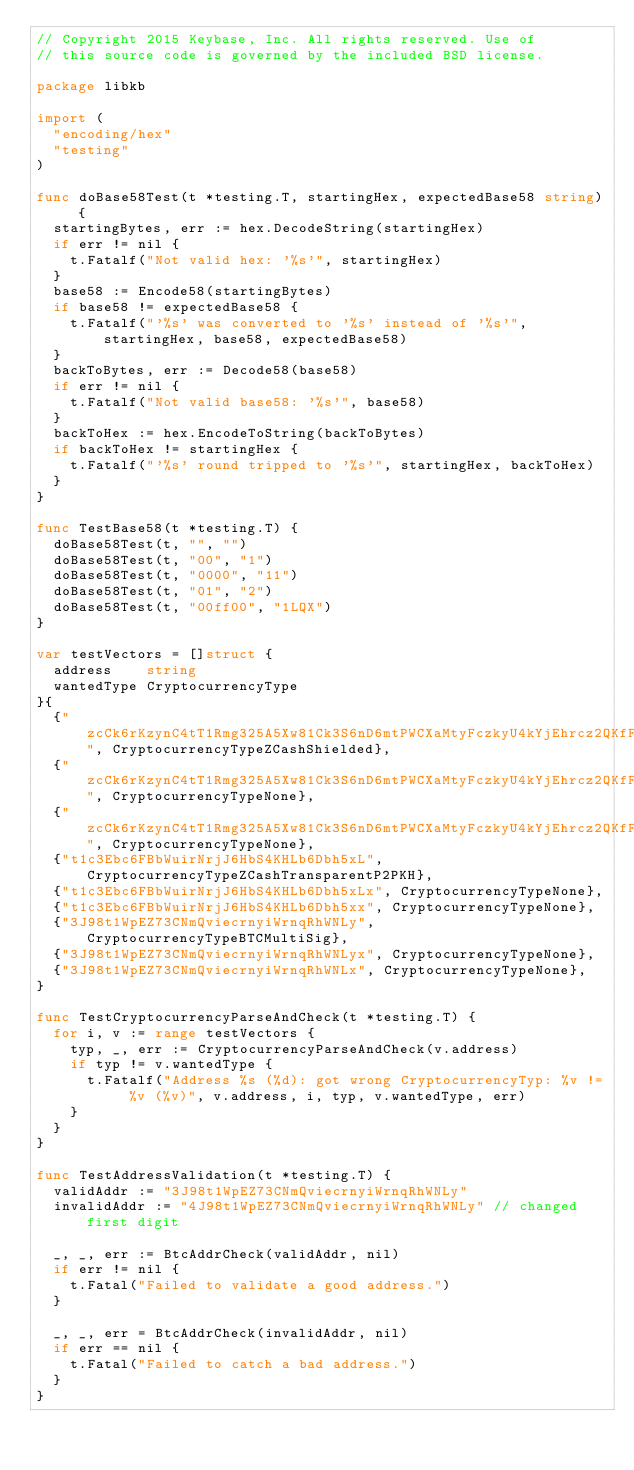<code> <loc_0><loc_0><loc_500><loc_500><_Go_>// Copyright 2015 Keybase, Inc. All rights reserved. Use of
// this source code is governed by the included BSD license.

package libkb

import (
	"encoding/hex"
	"testing"
)

func doBase58Test(t *testing.T, startingHex, expectedBase58 string) {
	startingBytes, err := hex.DecodeString(startingHex)
	if err != nil {
		t.Fatalf("Not valid hex: '%s'", startingHex)
	}
	base58 := Encode58(startingBytes)
	if base58 != expectedBase58 {
		t.Fatalf("'%s' was converted to '%s' instead of '%s'", startingHex, base58, expectedBase58)
	}
	backToBytes, err := Decode58(base58)
	if err != nil {
		t.Fatalf("Not valid base58: '%s'", base58)
	}
	backToHex := hex.EncodeToString(backToBytes)
	if backToHex != startingHex {
		t.Fatalf("'%s' round tripped to '%s'", startingHex, backToHex)
	}
}

func TestBase58(t *testing.T) {
	doBase58Test(t, "", "")
	doBase58Test(t, "00", "1")
	doBase58Test(t, "0000", "11")
	doBase58Test(t, "01", "2")
	doBase58Test(t, "00ff00", "1LQX")
}

var testVectors = []struct {
	address    string
	wantedType CryptocurrencyType
}{
	{"zcCk6rKzynC4tT1Rmg325A5Xw81Ck3S6nD6mtPWCXaMtyFczkyU4kYjEhrcz2QKfF5T2siWGyJNxWo43XWT3qk5YpPhFGj2", CryptocurrencyTypeZCashShielded},
	{"zcCk6rKzynC4tT1Rmg325A5Xw81Ck3S6nD6mtPWCXaMtyFczkyU4kYjEhrcz2QKfF5T2siWGyJNxWo43XWT3qk5YpPhFGj2x", CryptocurrencyTypeNone},
	{"zcCk6rKzynC4tT1Rmg325A5Xw81Ck3S6nD6mtPWCXaMtyFczkyU4kYjEhrcz2QKfF5T2siWGyJNxWo43XWT3qk5YpPhFGj3", CryptocurrencyTypeNone},
	{"t1c3Ebc6FBbWuirNrjJ6HbS4KHLb6Dbh5xL", CryptocurrencyTypeZCashTransparentP2PKH},
	{"t1c3Ebc6FBbWuirNrjJ6HbS4KHLb6Dbh5xLx", CryptocurrencyTypeNone},
	{"t1c3Ebc6FBbWuirNrjJ6HbS4KHLb6Dbh5xx", CryptocurrencyTypeNone},
	{"3J98t1WpEZ73CNmQviecrnyiWrnqRhWNLy", CryptocurrencyTypeBTCMultiSig},
	{"3J98t1WpEZ73CNmQviecrnyiWrnqRhWNLyx", CryptocurrencyTypeNone},
	{"3J98t1WpEZ73CNmQviecrnyiWrnqRhWNLx", CryptocurrencyTypeNone},
}

func TestCryptocurrencyParseAndCheck(t *testing.T) {
	for i, v := range testVectors {
		typ, _, err := CryptocurrencyParseAndCheck(v.address)
		if typ != v.wantedType {
			t.Fatalf("Address %s (%d): got wrong CryptocurrencyTyp: %v != %v (%v)", v.address, i, typ, v.wantedType, err)
		}
	}
}

func TestAddressValidation(t *testing.T) {
	validAddr := "3J98t1WpEZ73CNmQviecrnyiWrnqRhWNLy"
	invalidAddr := "4J98t1WpEZ73CNmQviecrnyiWrnqRhWNLy" // changed first digit

	_, _, err := BtcAddrCheck(validAddr, nil)
	if err != nil {
		t.Fatal("Failed to validate a good address.")
	}

	_, _, err = BtcAddrCheck(invalidAddr, nil)
	if err == nil {
		t.Fatal("Failed to catch a bad address.")
	}
}
</code> 